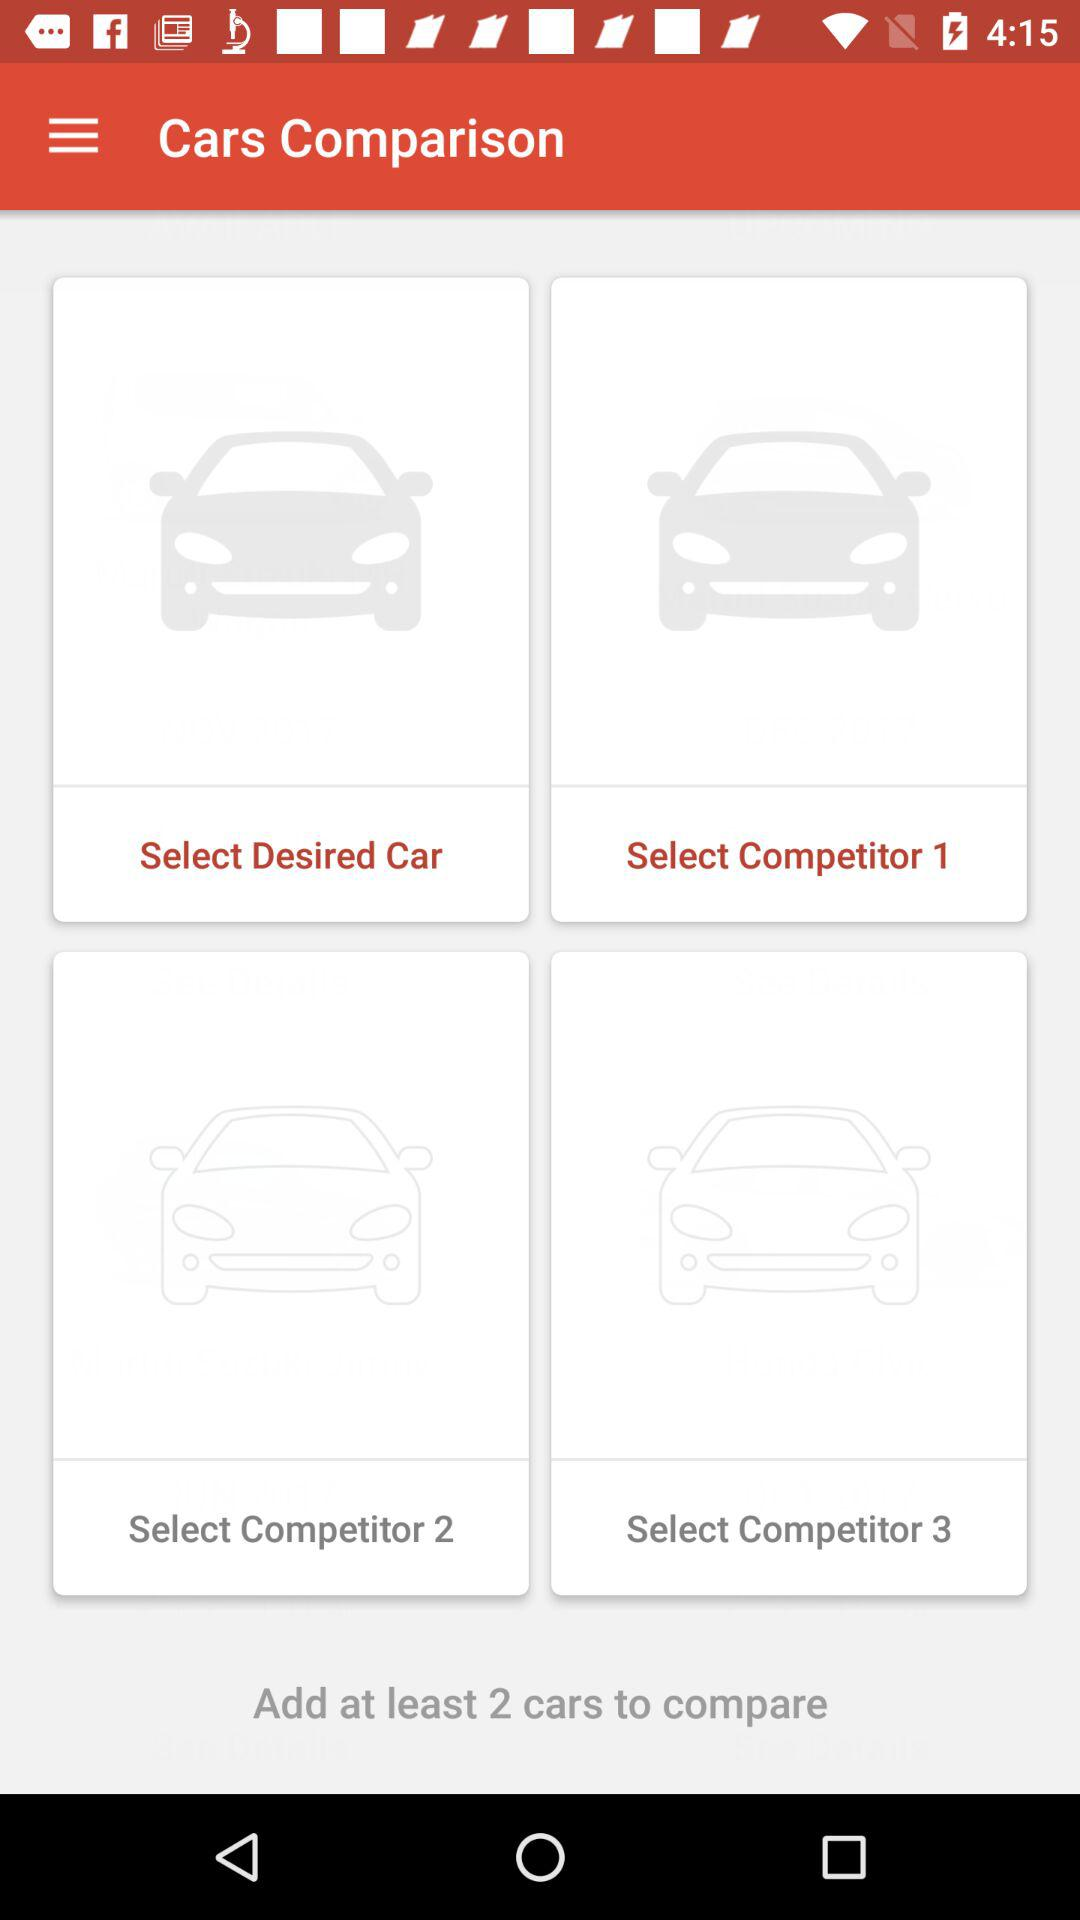How many minimum cars are required to compare? The minimum number of cars required to compare is 2. 